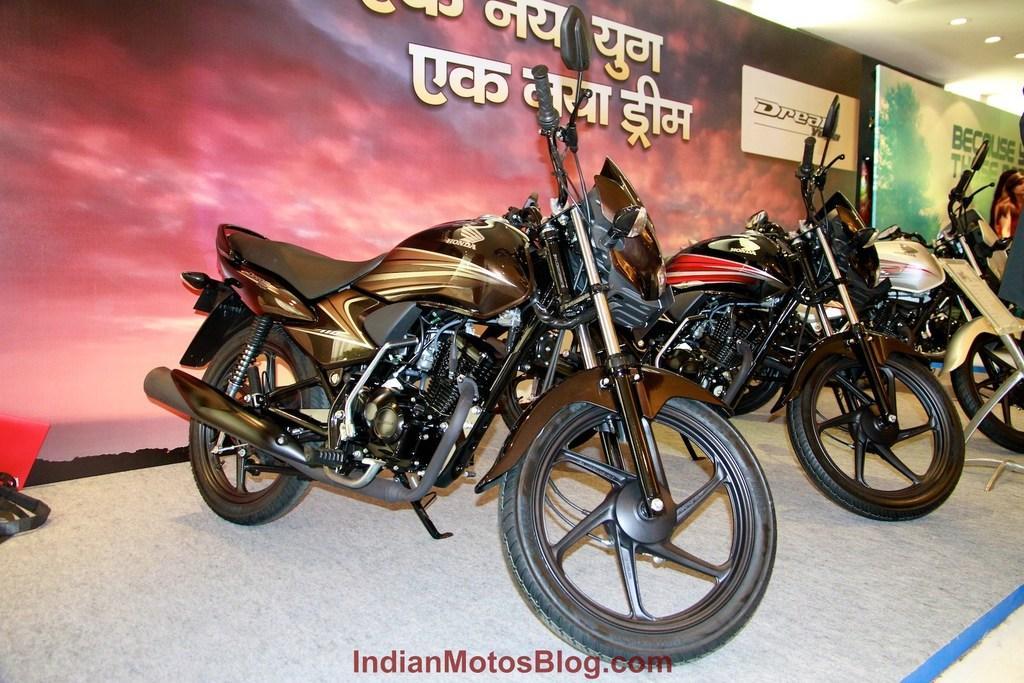Can you describe this image briefly? As we can see in the image there are black color motorcycles and banners. On banners there is some matter written. At the top there are lights. 